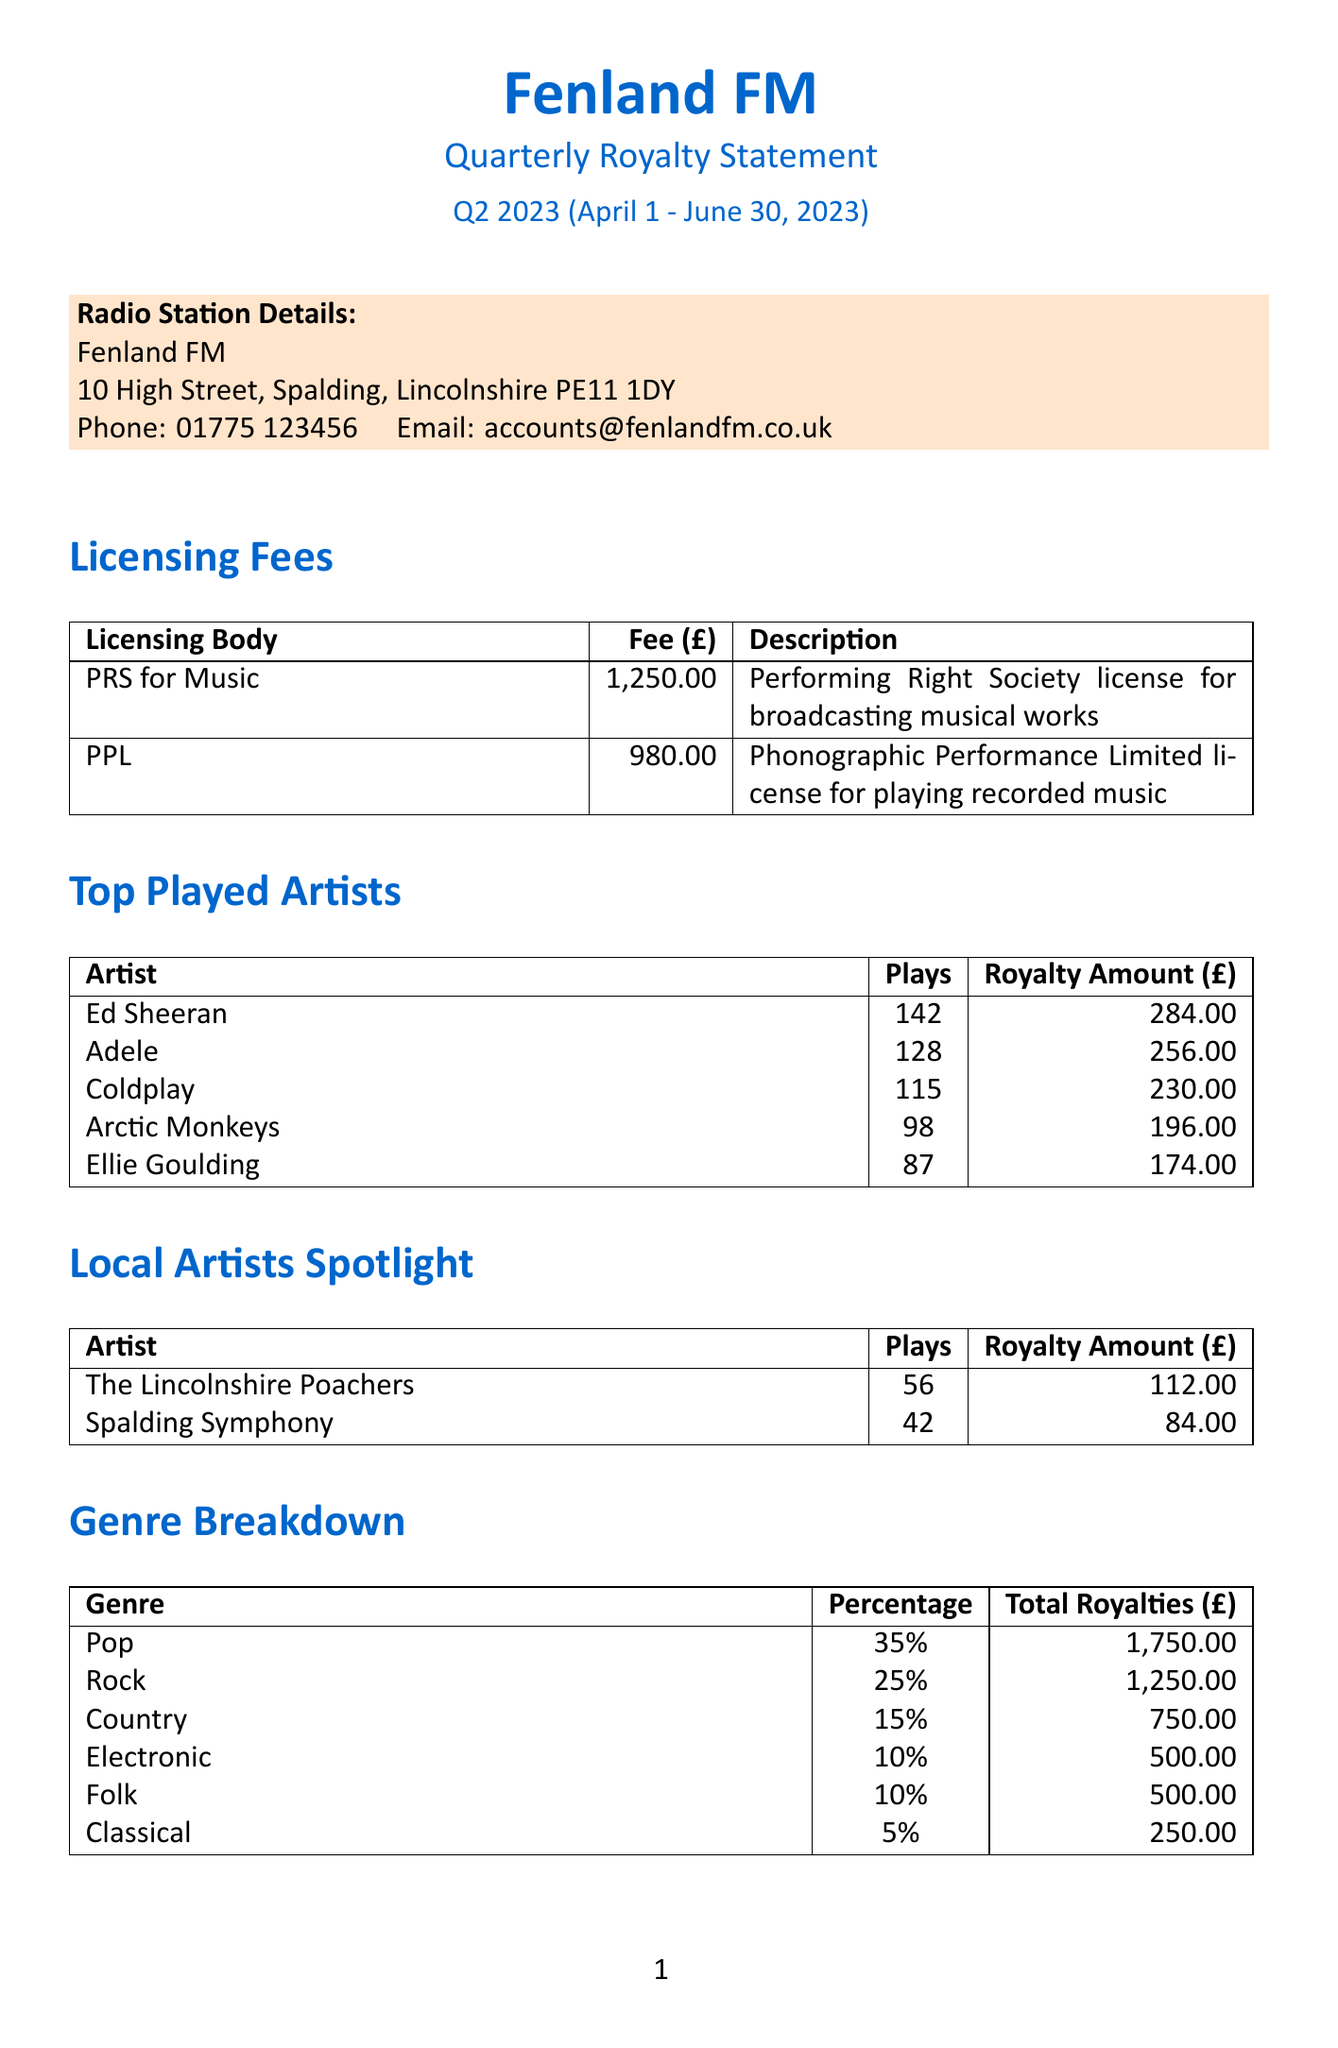what is the total tracks played? The total tracks played is stated in the summary section of the document as 3,850.
Answer: 3,850 how much is the licensing fee for PPL? The licensing fee for PPL is listed in the licensing fees section as 980.00.
Answer: 980.00 who is the host of the program "Lincolnshire Legends"? The host of "Lincolnshire Legends" is mentioned in the special programs section as Sarah Thompson.
Answer: Sarah Thompson what percentage of total royalties comes from the Pop genre? The document specifies that the Pop genre accounts for 35% of the total royalties.
Answer: 35% what is the royalty amount for Coldplay? The royalty amount for Coldplay is provided in the top played artists section as 230.00.
Answer: 230.00 how many plays did The Lincolnshire Poachers have? The number of plays for The Lincolnshire Poachers is listed as 56 in the local artists spotlight section.
Answer: 56 what is the grand total amount? The grand total amount is summarized in the document as 9,930.00.
Answer: 9,930.00 what is the total of licensing fees? The document indicates the total licensing fees as 2,230.00 in the summary section.
Answer: 2,230.00 what is the royalty amount for the program "Fenland Folk Hour"? The royalty amount for "Fenland Folk Hour" is detailed as 124.00 in the special programs section.
Answer: 124.00 